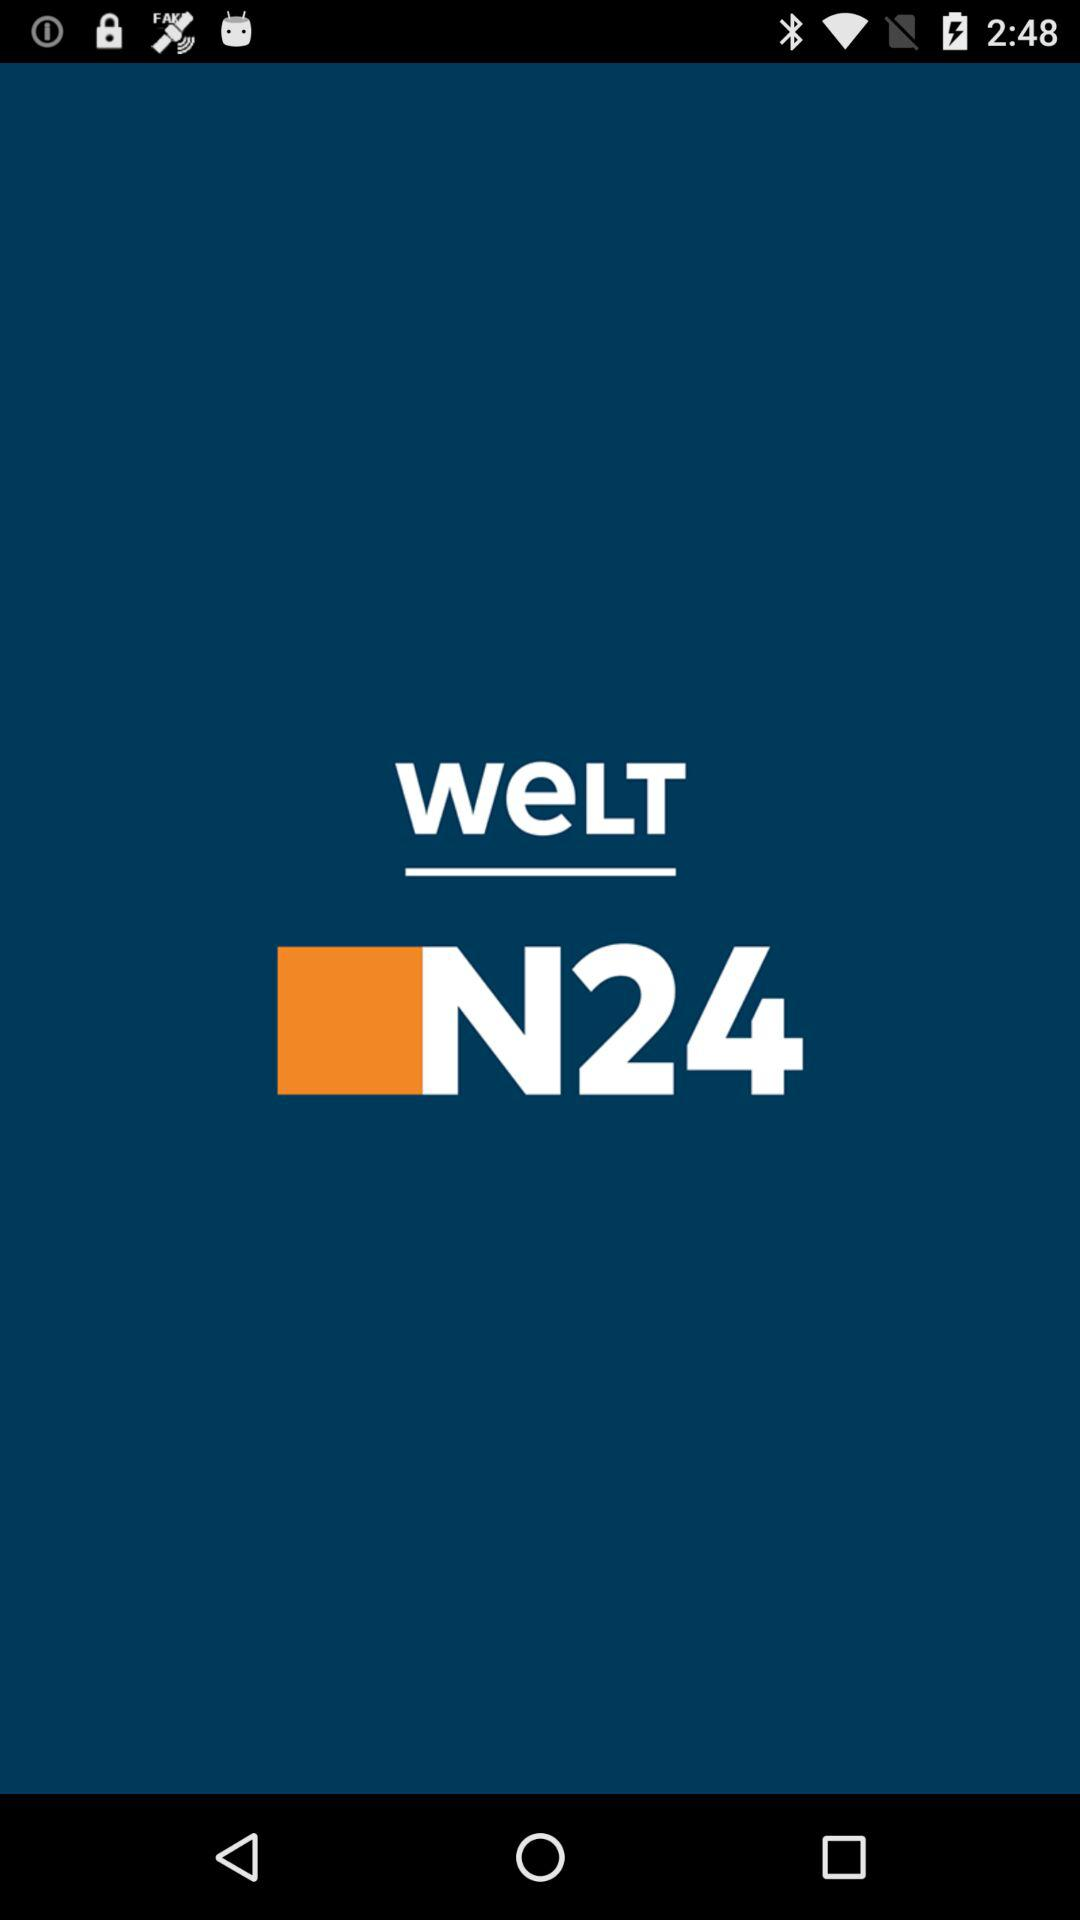What is the app name? The app name is "Welt N24". 